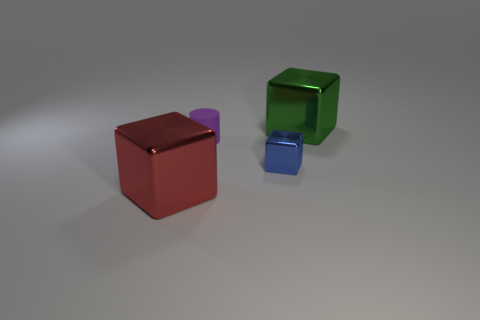Is there anything else that is the same shape as the tiny purple object?
Provide a succinct answer. No. Is there anything else that is the same material as the purple cylinder?
Keep it short and to the point. No. Does the green cube have the same material as the red thing?
Provide a succinct answer. Yes. What number of blocks are small cyan shiny objects or rubber things?
Your answer should be very brief. 0. The large block in front of the large block behind the red block is what color?
Your answer should be compact. Red. How many cubes are on the right side of the small blue shiny object that is in front of the small thing that is on the left side of the blue cube?
Offer a terse response. 1. There is a metal thing to the right of the blue block; does it have the same shape as the object in front of the blue metal object?
Ensure brevity in your answer.  Yes. How many objects are blue things or big blue metallic balls?
Make the answer very short. 1. There is a big thing that is on the right side of the large metallic block that is in front of the large green object; what is its material?
Give a very brief answer. Metal. Is there another thing of the same color as the rubber thing?
Make the answer very short. No. 